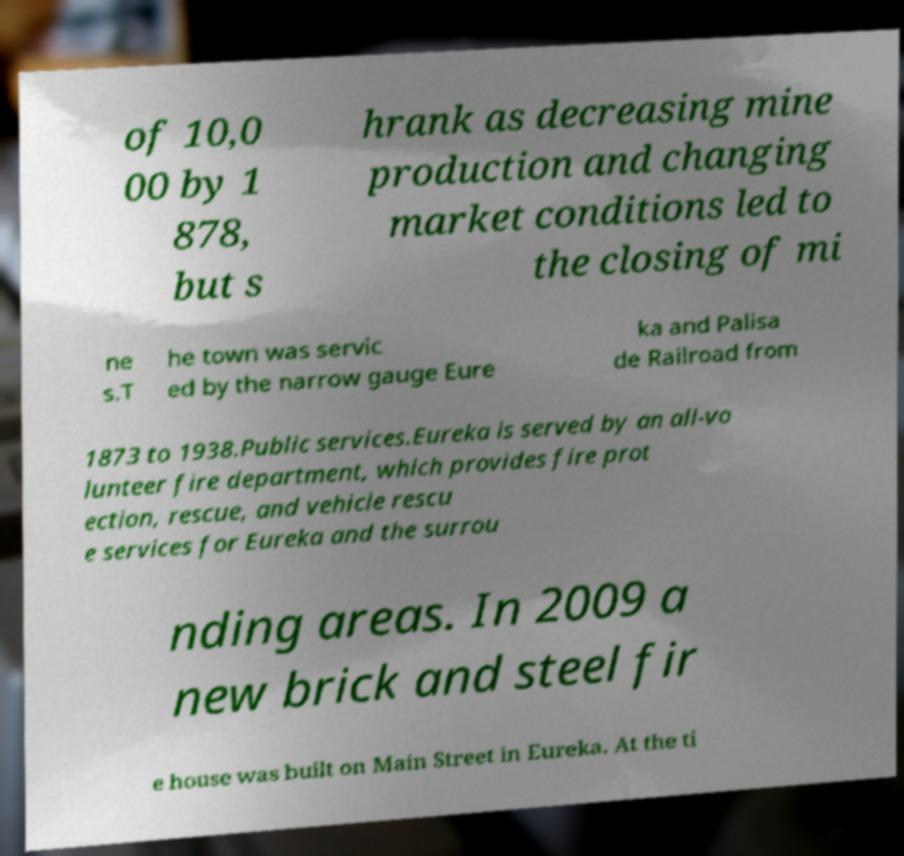I need the written content from this picture converted into text. Can you do that? of 10,0 00 by 1 878, but s hrank as decreasing mine production and changing market conditions led to the closing of mi ne s.T he town was servic ed by the narrow gauge Eure ka and Palisa de Railroad from 1873 to 1938.Public services.Eureka is served by an all-vo lunteer fire department, which provides fire prot ection, rescue, and vehicle rescu e services for Eureka and the surrou nding areas. In 2009 a new brick and steel fir e house was built on Main Street in Eureka. At the ti 